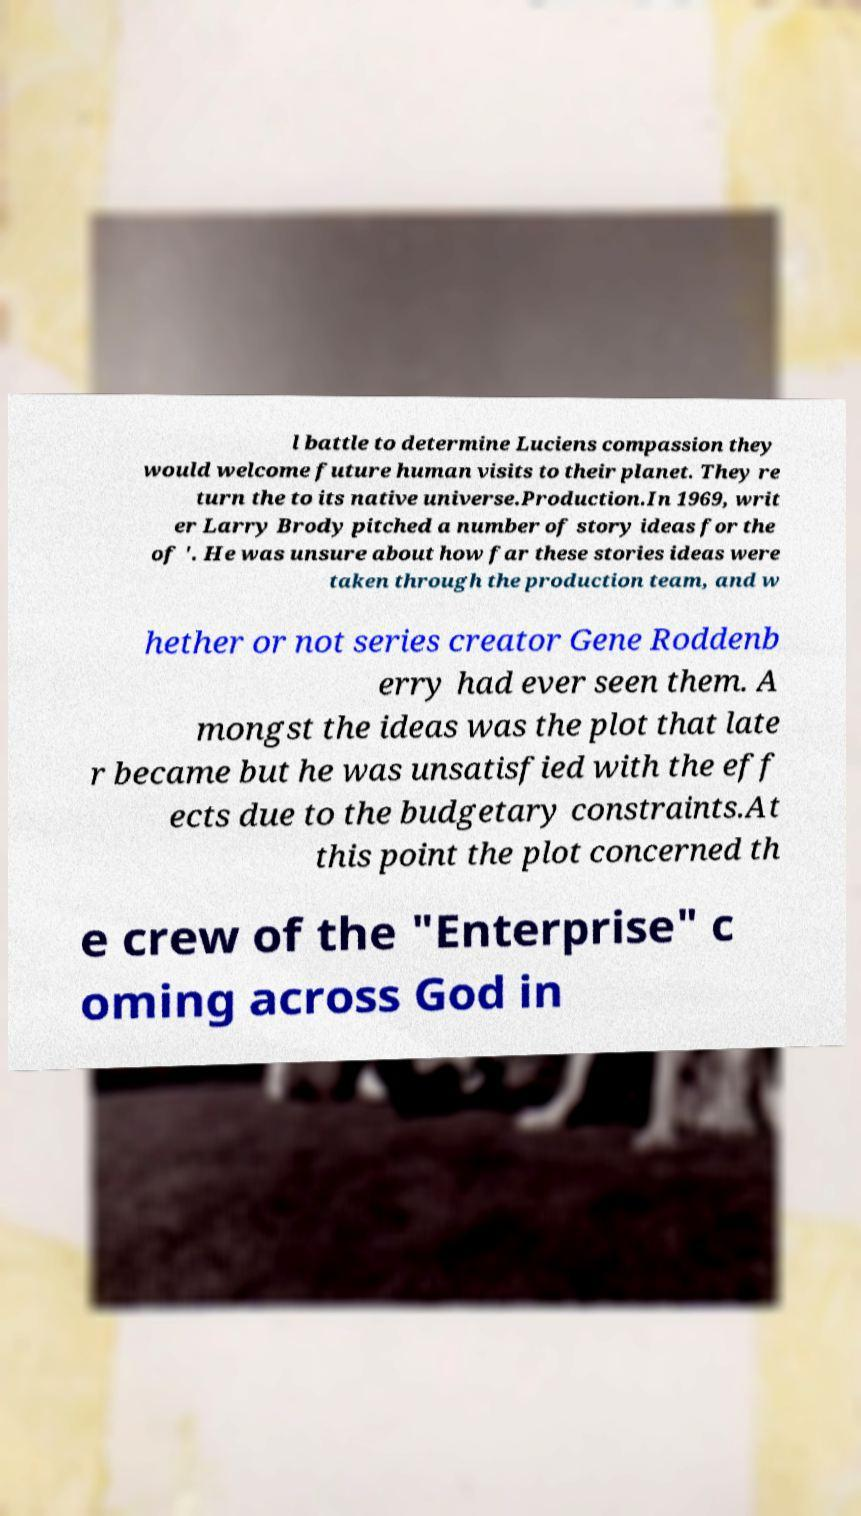Can you read and provide the text displayed in the image?This photo seems to have some interesting text. Can you extract and type it out for me? l battle to determine Luciens compassion they would welcome future human visits to their planet. They re turn the to its native universe.Production.In 1969, writ er Larry Brody pitched a number of story ideas for the of '. He was unsure about how far these stories ideas were taken through the production team, and w hether or not series creator Gene Roddenb erry had ever seen them. A mongst the ideas was the plot that late r became but he was unsatisfied with the eff ects due to the budgetary constraints.At this point the plot concerned th e crew of the "Enterprise" c oming across God in 